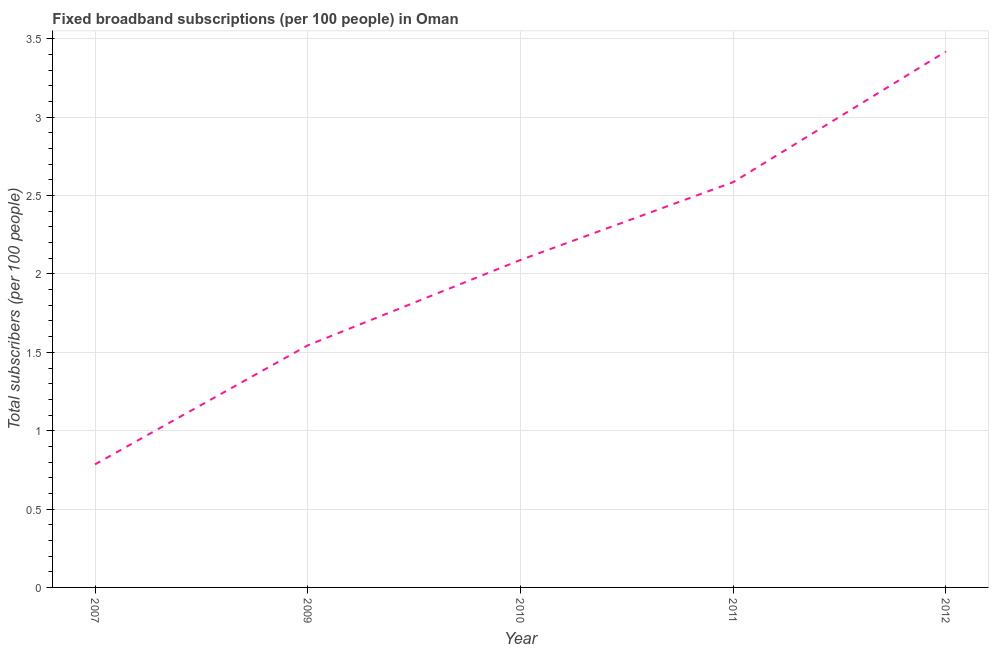What is the total number of fixed broadband subscriptions in 2007?
Provide a short and direct response. 0.79. Across all years, what is the maximum total number of fixed broadband subscriptions?
Your answer should be very brief. 3.42. Across all years, what is the minimum total number of fixed broadband subscriptions?
Give a very brief answer. 0.79. What is the sum of the total number of fixed broadband subscriptions?
Give a very brief answer. 10.42. What is the difference between the total number of fixed broadband subscriptions in 2011 and 2012?
Make the answer very short. -0.83. What is the average total number of fixed broadband subscriptions per year?
Provide a succinct answer. 2.08. What is the median total number of fixed broadband subscriptions?
Your answer should be very brief. 2.09. What is the ratio of the total number of fixed broadband subscriptions in 2007 to that in 2009?
Keep it short and to the point. 0.51. What is the difference between the highest and the second highest total number of fixed broadband subscriptions?
Offer a very short reply. 0.83. What is the difference between the highest and the lowest total number of fixed broadband subscriptions?
Offer a very short reply. 2.63. In how many years, is the total number of fixed broadband subscriptions greater than the average total number of fixed broadband subscriptions taken over all years?
Offer a terse response. 3. How many years are there in the graph?
Your answer should be compact. 5. What is the difference between two consecutive major ticks on the Y-axis?
Make the answer very short. 0.5. Are the values on the major ticks of Y-axis written in scientific E-notation?
Provide a short and direct response. No. Does the graph contain any zero values?
Make the answer very short. No. What is the title of the graph?
Keep it short and to the point. Fixed broadband subscriptions (per 100 people) in Oman. What is the label or title of the Y-axis?
Provide a short and direct response. Total subscribers (per 100 people). What is the Total subscribers (per 100 people) of 2007?
Your response must be concise. 0.79. What is the Total subscribers (per 100 people) of 2009?
Ensure brevity in your answer.  1.54. What is the Total subscribers (per 100 people) in 2010?
Provide a short and direct response. 2.09. What is the Total subscribers (per 100 people) in 2011?
Your answer should be compact. 2.59. What is the Total subscribers (per 100 people) of 2012?
Offer a very short reply. 3.42. What is the difference between the Total subscribers (per 100 people) in 2007 and 2009?
Provide a short and direct response. -0.76. What is the difference between the Total subscribers (per 100 people) in 2007 and 2010?
Your response must be concise. -1.3. What is the difference between the Total subscribers (per 100 people) in 2007 and 2011?
Provide a succinct answer. -1.8. What is the difference between the Total subscribers (per 100 people) in 2007 and 2012?
Offer a terse response. -2.63. What is the difference between the Total subscribers (per 100 people) in 2009 and 2010?
Provide a succinct answer. -0.54. What is the difference between the Total subscribers (per 100 people) in 2009 and 2011?
Keep it short and to the point. -1.04. What is the difference between the Total subscribers (per 100 people) in 2009 and 2012?
Keep it short and to the point. -1.88. What is the difference between the Total subscribers (per 100 people) in 2010 and 2011?
Keep it short and to the point. -0.5. What is the difference between the Total subscribers (per 100 people) in 2010 and 2012?
Offer a very short reply. -1.33. What is the difference between the Total subscribers (per 100 people) in 2011 and 2012?
Make the answer very short. -0.83. What is the ratio of the Total subscribers (per 100 people) in 2007 to that in 2009?
Provide a short and direct response. 0.51. What is the ratio of the Total subscribers (per 100 people) in 2007 to that in 2010?
Keep it short and to the point. 0.38. What is the ratio of the Total subscribers (per 100 people) in 2007 to that in 2011?
Offer a terse response. 0.3. What is the ratio of the Total subscribers (per 100 people) in 2007 to that in 2012?
Ensure brevity in your answer.  0.23. What is the ratio of the Total subscribers (per 100 people) in 2009 to that in 2010?
Your answer should be compact. 0.74. What is the ratio of the Total subscribers (per 100 people) in 2009 to that in 2011?
Keep it short and to the point. 0.6. What is the ratio of the Total subscribers (per 100 people) in 2009 to that in 2012?
Give a very brief answer. 0.45. What is the ratio of the Total subscribers (per 100 people) in 2010 to that in 2011?
Give a very brief answer. 0.81. What is the ratio of the Total subscribers (per 100 people) in 2010 to that in 2012?
Make the answer very short. 0.61. What is the ratio of the Total subscribers (per 100 people) in 2011 to that in 2012?
Give a very brief answer. 0.76. 